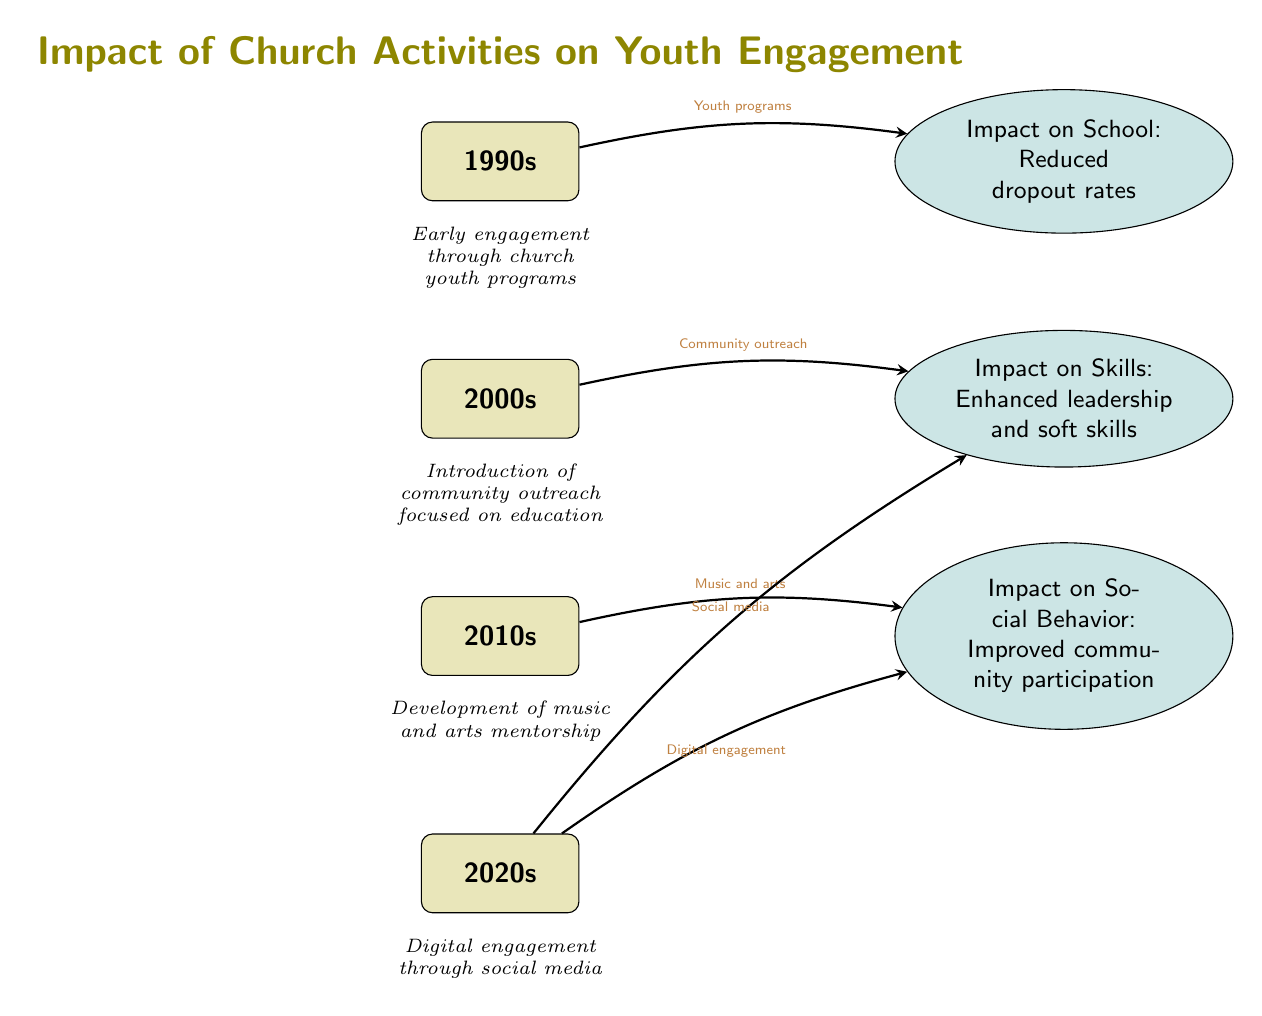What are the four decades represented in the timeline? The diagram lists four decades: 1990s, 2000s, 2010s, and 2020s along the vertical timeline.
Answer: 1990s, 2000s, 2010s, 2020s What is the impact of church activities on youth engagement in the 2000s? The impact noted for the 2000s is "Enhanced leadership and soft skills" which corresponds to the community outreach initiatives during that decade.
Answer: Enhanced leadership and soft skills How many impacts are displayed in the diagram? The diagram shows four impacts, each corresponding to the decade nodes. They are related to school, skills, social behavior, and social media.
Answer: 4 Which decade's activity included music and arts? The decade that included music and arts is the 2010s, which is linked to the improved social behavior impact.
Answer: 2010s What type of engagement did the 2020s focus on? The 2020s focused on "Digital engagement" through social media and improved social behavior.
Answer: Digital engagement What does the arrow between the 1990s and the impact on school indicate? The arrow represents a positive relationship where youth programs in the 1990s led to reduced dropout rates, indicating effective church influence on educational persistence.
Answer: Youth programs Which decade's impact includes community participation? The impact associated with improved community participation arises from activities in the 2010s, indicating a cumulative effect of previous engagement strategies.
Answer: 2010s What was stated as the early engagement strategy of the church? The early engagement strategy noted in the diagram is "Early engagement through church youth programs," which significantly influenced the youth in the 1990s.
Answer: Early engagement through church youth programs How did social media influence skills in the 2020s? Social media in the 2020s plays a role, as indicated in the diagram, by facilitating an impact on skills development, enhancing the youth's outreach and learning opportunities.
Answer: Impact on skills 